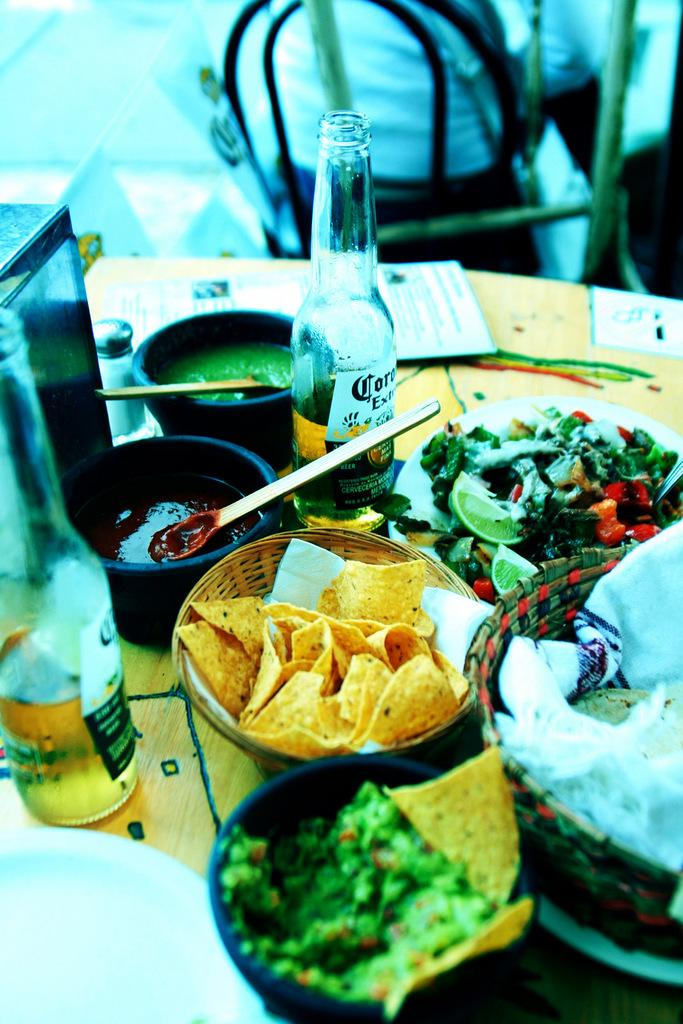<image>
Share a concise interpretation of the image provided. A variety of Mexican food is displayed along with two bottles of Corona. 